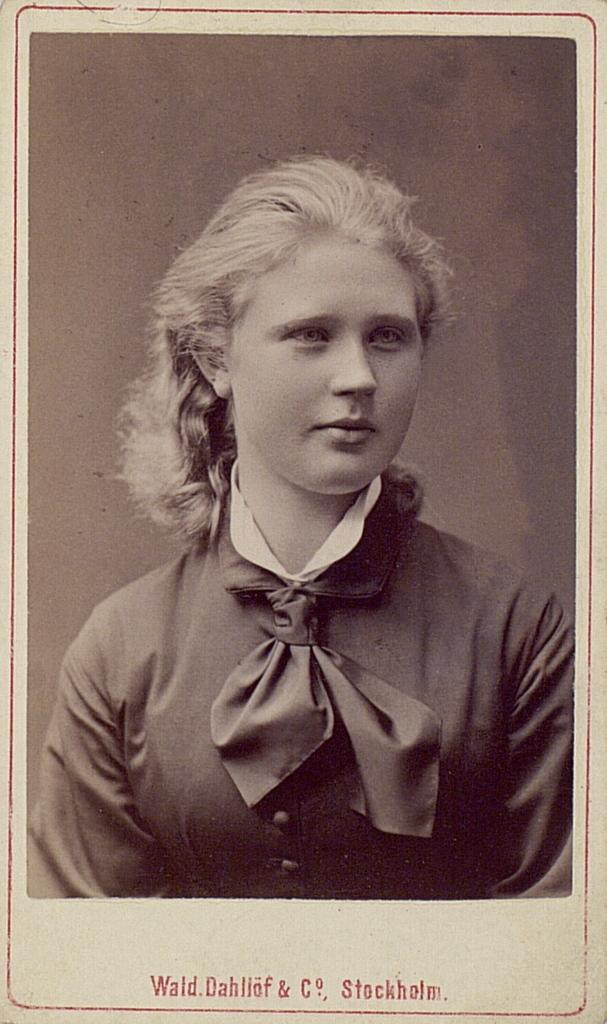What is the main subject of the image? There is a photograph of a girl in the image. Is there any text present in the image? Yes, text is written at the bottom of the image. What type of powder is being used by the girl in the image? There is no powder visible in the image, as it only features a photograph of a girl and text at the bottom. 